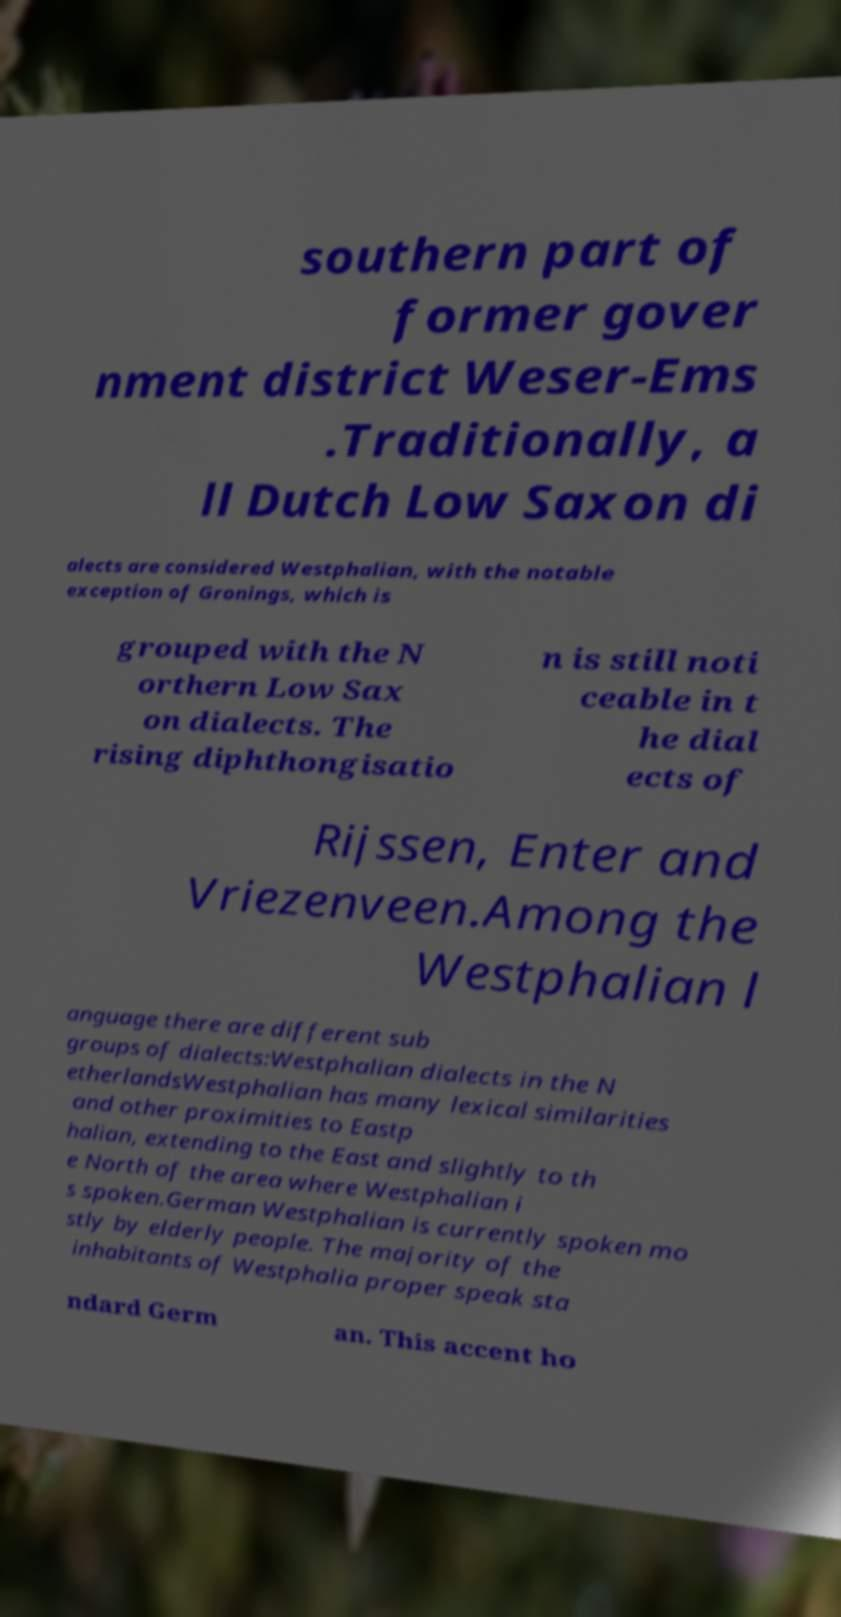Please read and relay the text visible in this image. What does it say? southern part of former gover nment district Weser-Ems .Traditionally, a ll Dutch Low Saxon di alects are considered Westphalian, with the notable exception of Gronings, which is grouped with the N orthern Low Sax on dialects. The rising diphthongisatio n is still noti ceable in t he dial ects of Rijssen, Enter and Vriezenveen.Among the Westphalian l anguage there are different sub groups of dialects:Westphalian dialects in the N etherlandsWestphalian has many lexical similarities and other proximities to Eastp halian, extending to the East and slightly to th e North of the area where Westphalian i s spoken.German Westphalian is currently spoken mo stly by elderly people. The majority of the inhabitants of Westphalia proper speak sta ndard Germ an. This accent ho 